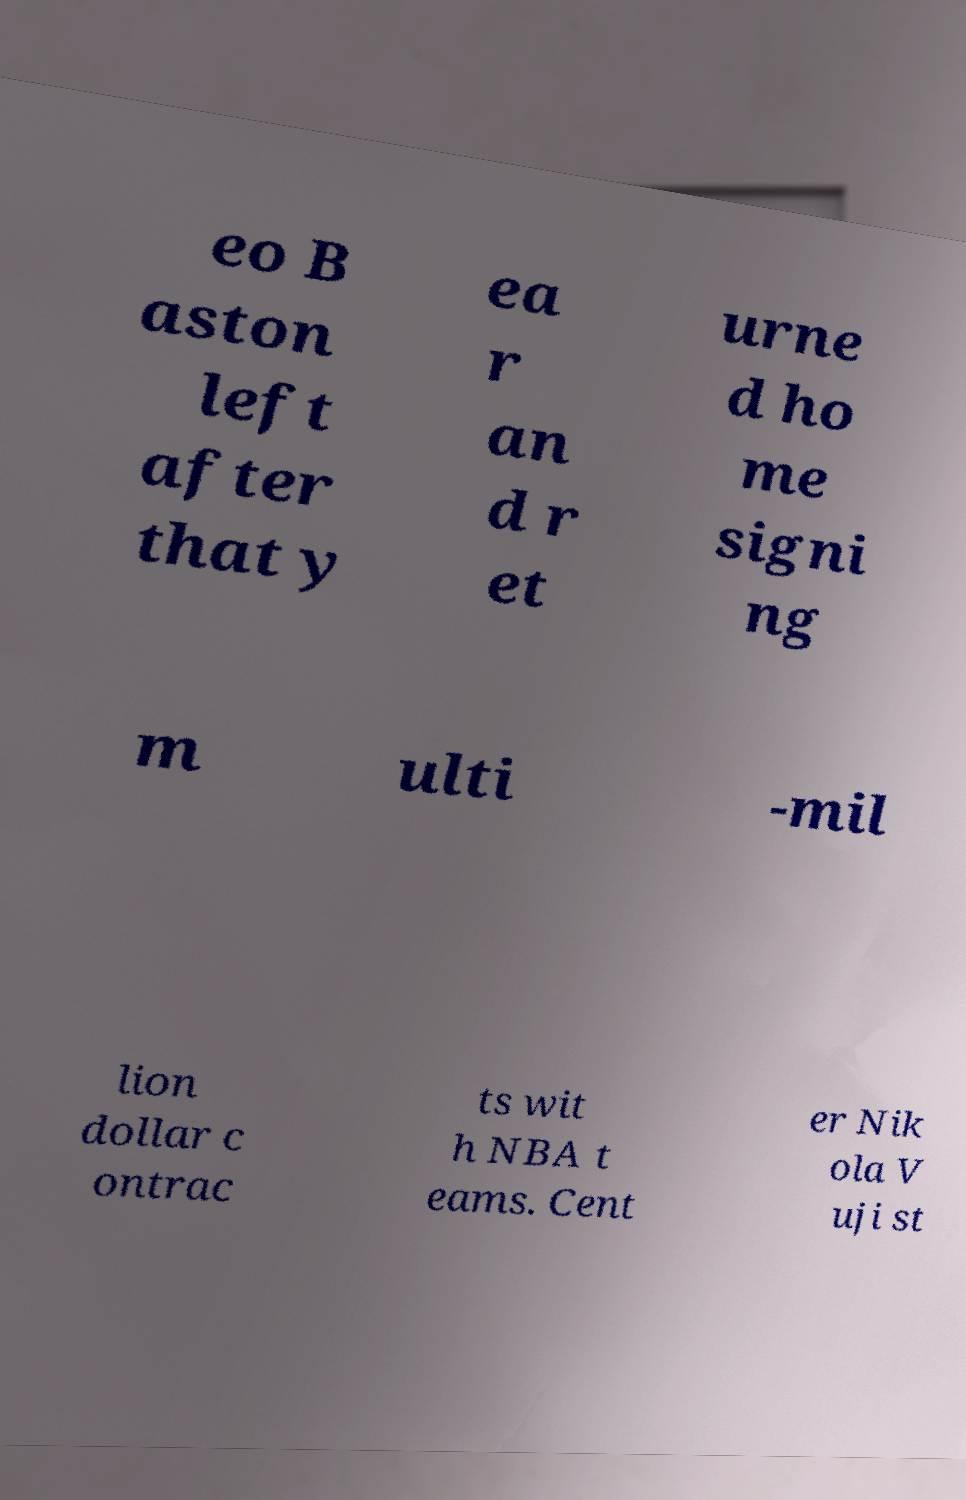Could you assist in decoding the text presented in this image and type it out clearly? eo B aston left after that y ea r an d r et urne d ho me signi ng m ulti -mil lion dollar c ontrac ts wit h NBA t eams. Cent er Nik ola V uji st 